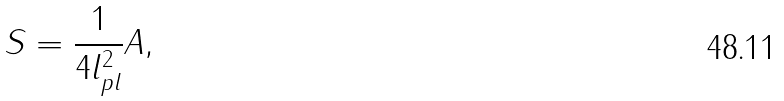Convert formula to latex. <formula><loc_0><loc_0><loc_500><loc_500>S = \frac { 1 } { 4 l ^ { 2 } _ { p l } } A ,</formula> 